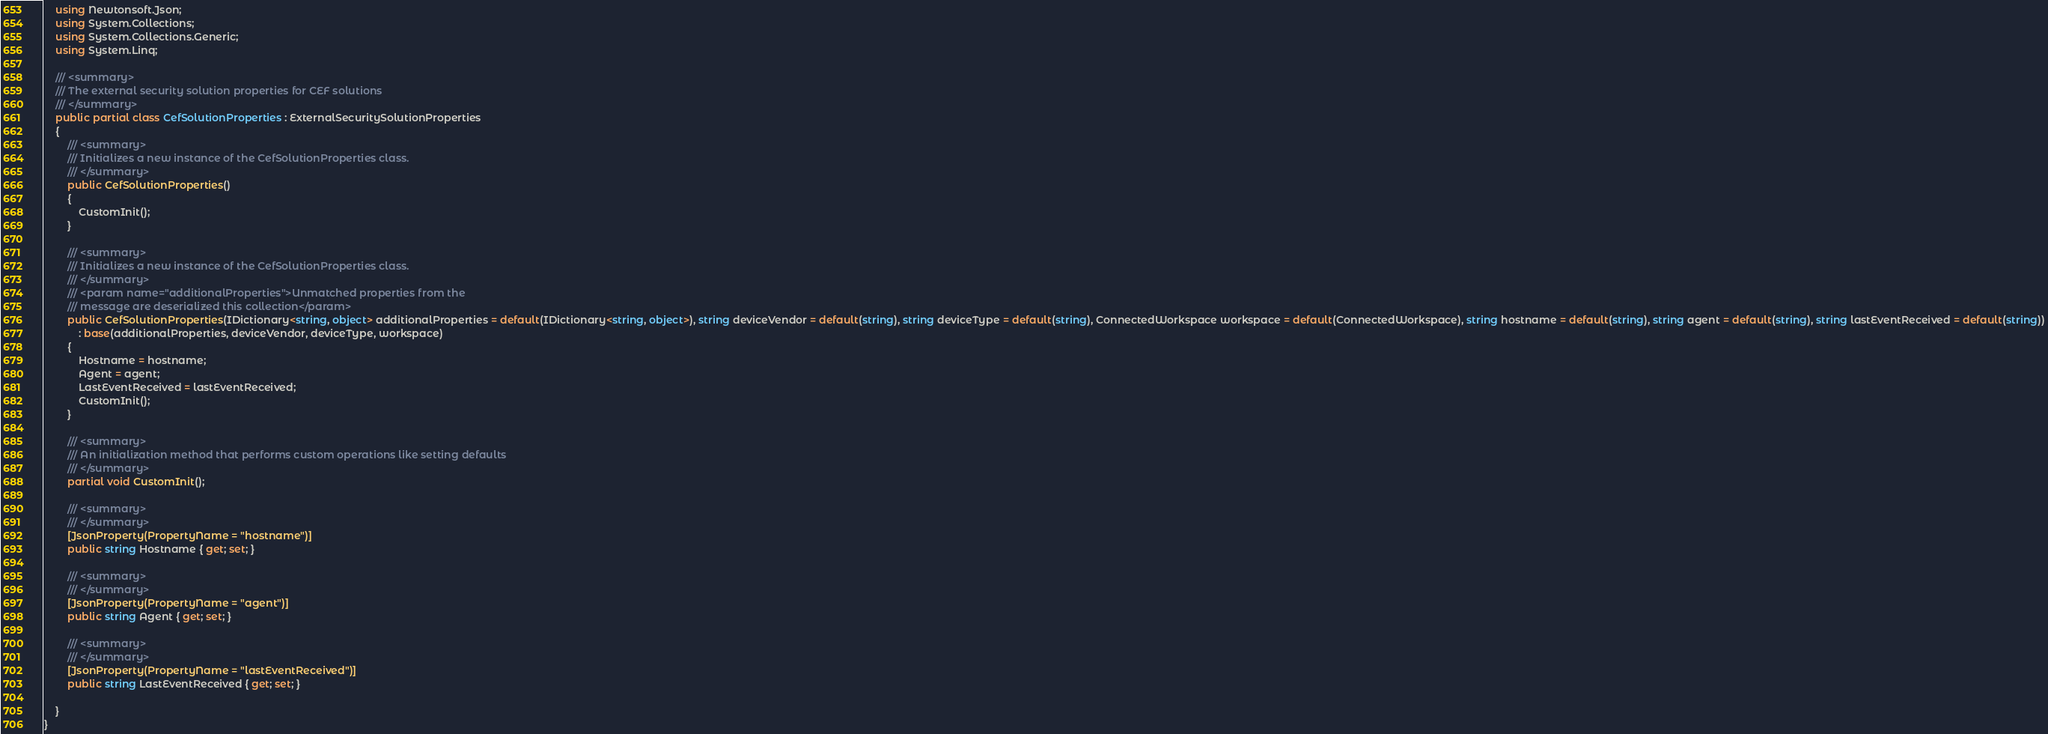<code> <loc_0><loc_0><loc_500><loc_500><_C#_>    using Newtonsoft.Json;
    using System.Collections;
    using System.Collections.Generic;
    using System.Linq;

    /// <summary>
    /// The external security solution properties for CEF solutions
    /// </summary>
    public partial class CefSolutionProperties : ExternalSecuritySolutionProperties
    {
        /// <summary>
        /// Initializes a new instance of the CefSolutionProperties class.
        /// </summary>
        public CefSolutionProperties()
        {
            CustomInit();
        }

        /// <summary>
        /// Initializes a new instance of the CefSolutionProperties class.
        /// </summary>
        /// <param name="additionalProperties">Unmatched properties from the
        /// message are deserialized this collection</param>
        public CefSolutionProperties(IDictionary<string, object> additionalProperties = default(IDictionary<string, object>), string deviceVendor = default(string), string deviceType = default(string), ConnectedWorkspace workspace = default(ConnectedWorkspace), string hostname = default(string), string agent = default(string), string lastEventReceived = default(string))
            : base(additionalProperties, deviceVendor, deviceType, workspace)
        {
            Hostname = hostname;
            Agent = agent;
            LastEventReceived = lastEventReceived;
            CustomInit();
        }

        /// <summary>
        /// An initialization method that performs custom operations like setting defaults
        /// </summary>
        partial void CustomInit();

        /// <summary>
        /// </summary>
        [JsonProperty(PropertyName = "hostname")]
        public string Hostname { get; set; }

        /// <summary>
        /// </summary>
        [JsonProperty(PropertyName = "agent")]
        public string Agent { get; set; }

        /// <summary>
        /// </summary>
        [JsonProperty(PropertyName = "lastEventReceived")]
        public string LastEventReceived { get; set; }

    }
}
</code> 